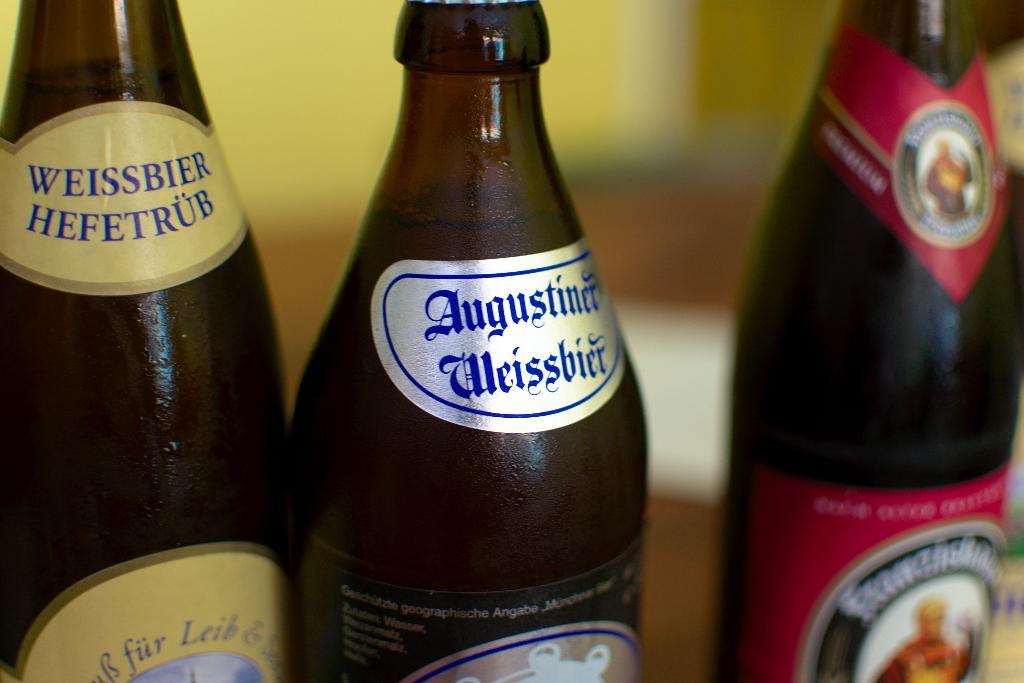What is the name of the beer on the far left?
Your response must be concise. Weissbier hefetrub. What is the name on the middle label?
Provide a short and direct response. Augustiner weissbier. 